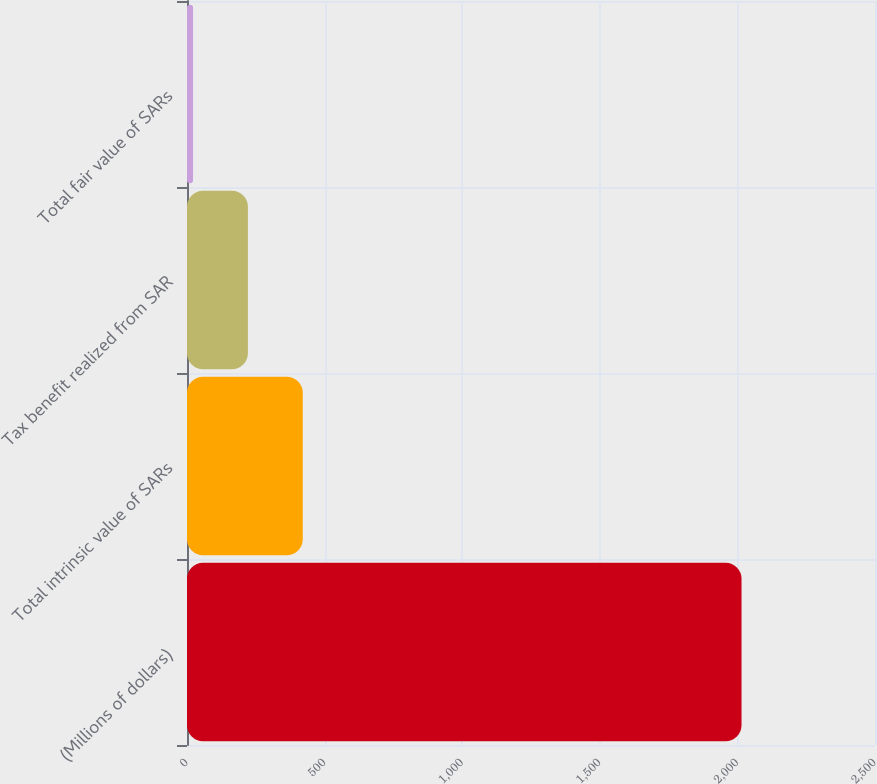Convert chart. <chart><loc_0><loc_0><loc_500><loc_500><bar_chart><fcel>(Millions of dollars)<fcel>Total intrinsic value of SARs<fcel>Tax benefit realized from SAR<fcel>Total fair value of SARs<nl><fcel>2015<fcel>420.6<fcel>221.3<fcel>22<nl></chart> 